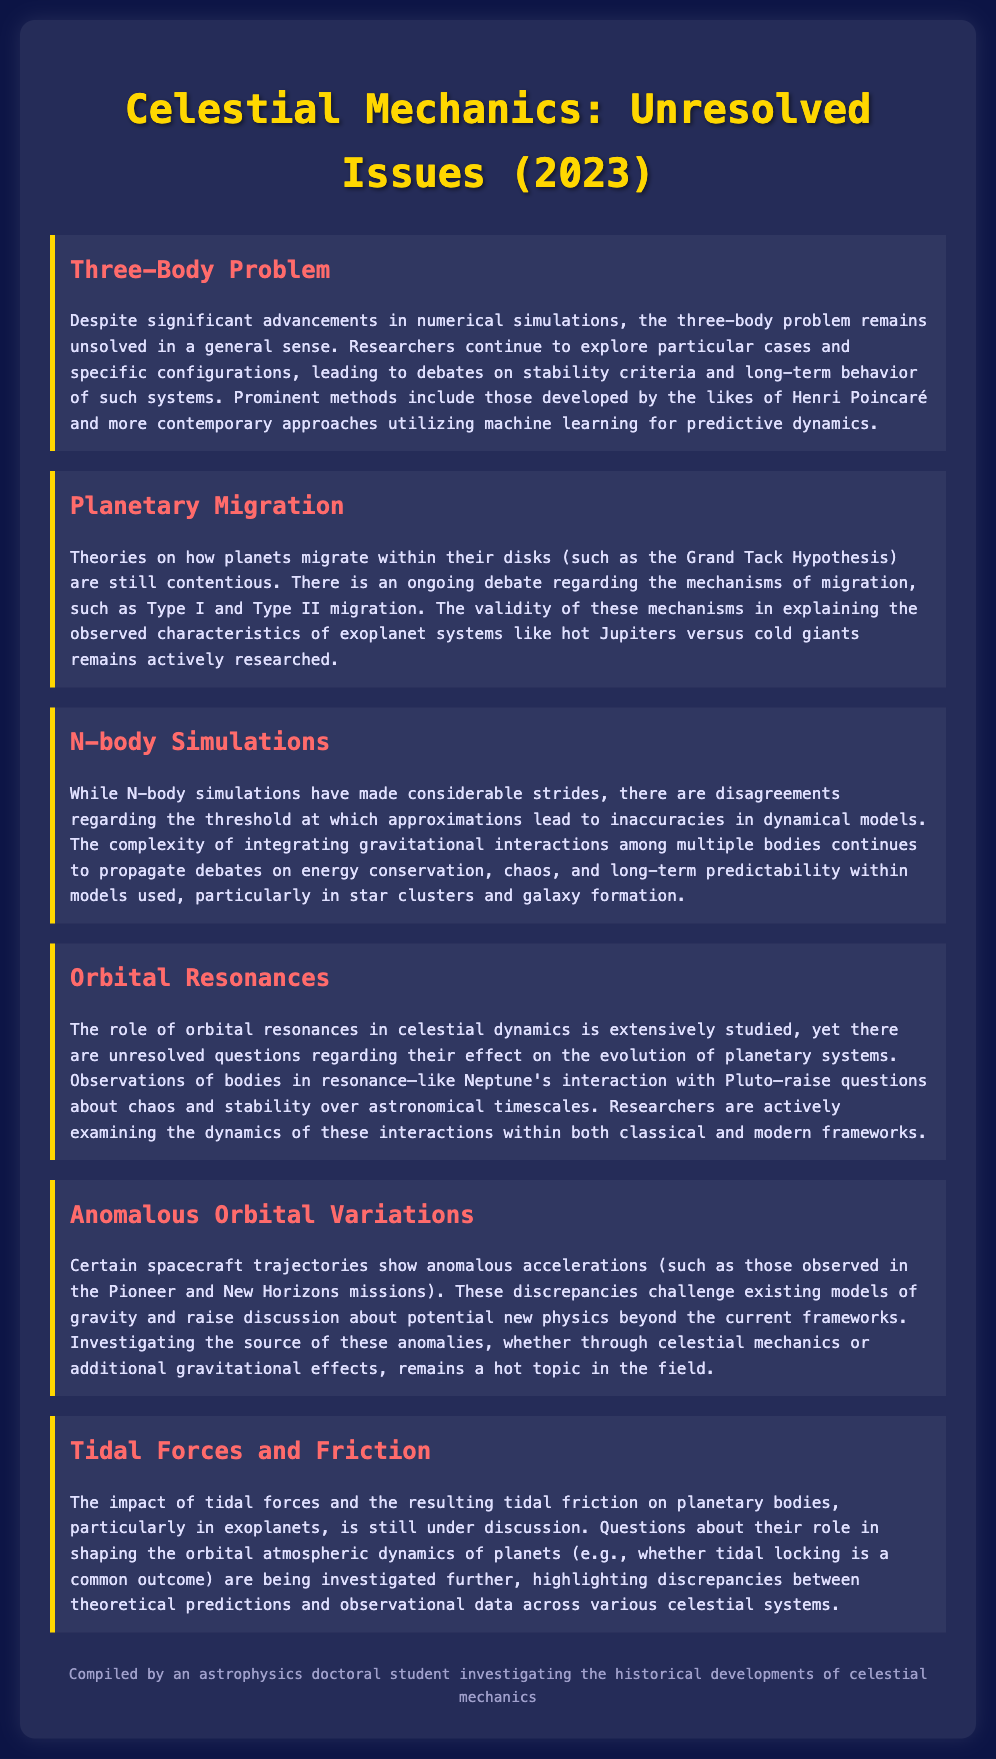What is the title of the document? The title is indicated prominently at the top of the document, presenting the overarching theme.
Answer: Celestial Mechanics: Unresolved Issues (2023) How many unresolved issues are mentioned in the document? The document lists six distinct unresolved issues, each highlighted in its own section.
Answer: Six Who developed significant methods related to the three-body problem? The document notes the contributions of notable figures in the history of celestial mechanics regarding this topic.
Answer: Henri Poincaré What is the Grand Tack Hypothesis associated with? This term references a specific theory within the context of planetary dynamics discussed in the document.
Answer: Planetary Migration Which two missions are mentioned in relation to anomalous accelerations? These missions are specifically cited as examples of spacecraft showing notable discrepancies in their trajectories.
Answer: Pioneer and New Horizons What aspect of exoplanets is under discussion in tidal forces and friction? The document refers to a common outcome that arises from the study of tidal forces affecting planetary bodies.
Answer: Tidal locking Which system's dynamics are being questioned in orbital resonances? The document highlights an interaction that raises significant questions within celestial dynamics.
Answer: Neptune's interaction with Pluto 